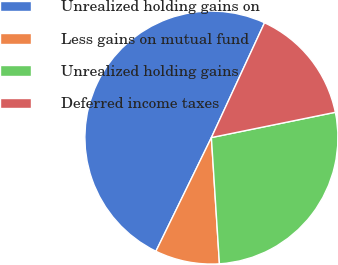Convert chart to OTSL. <chart><loc_0><loc_0><loc_500><loc_500><pie_chart><fcel>Unrealized holding gains on<fcel>Less gains on mutual fund<fcel>Unrealized holding gains<fcel>Deferred income taxes<nl><fcel>49.67%<fcel>8.24%<fcel>27.19%<fcel>14.9%<nl></chart> 